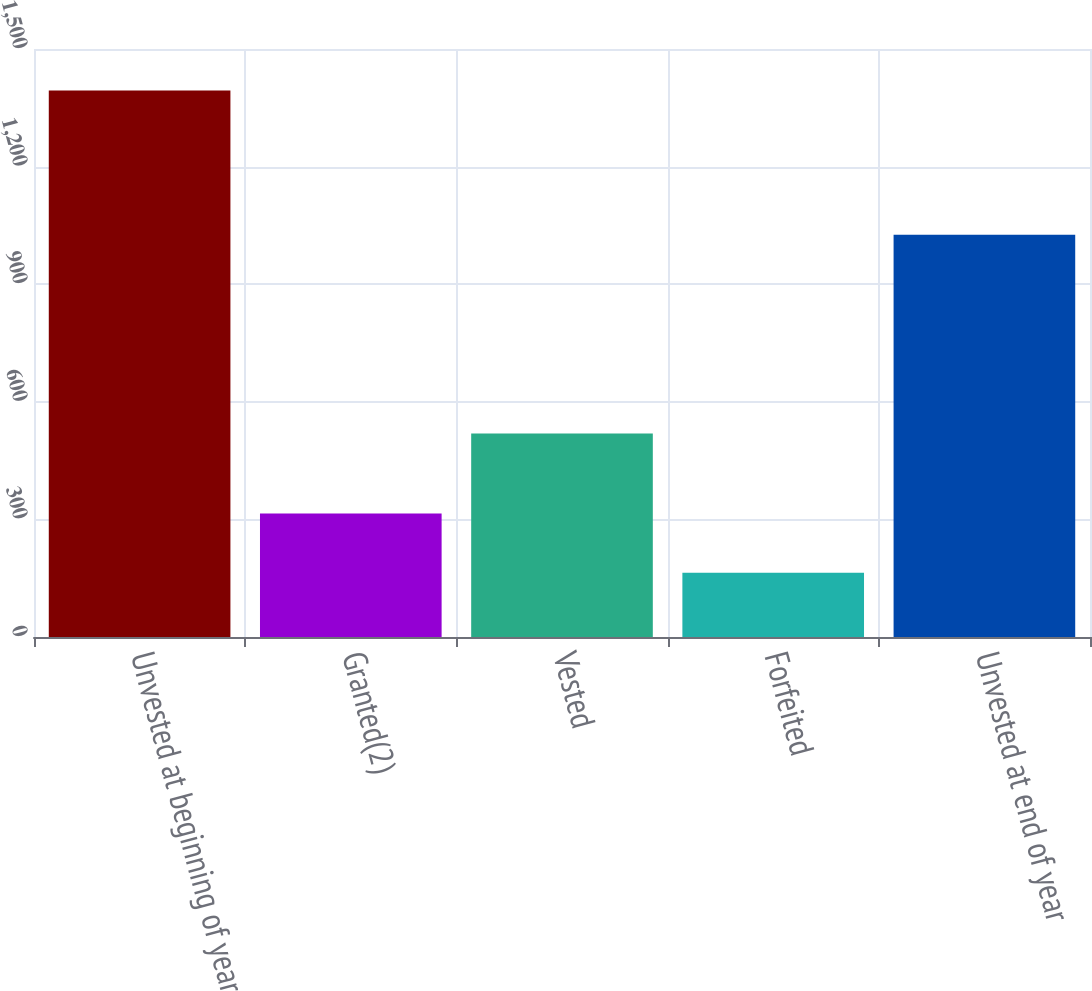Convert chart. <chart><loc_0><loc_0><loc_500><loc_500><bar_chart><fcel>Unvested at beginning of year<fcel>Granted(2)<fcel>Vested<fcel>Forfeited<fcel>Unvested at end of year<nl><fcel>1394<fcel>315<fcel>519<fcel>164<fcel>1026<nl></chart> 